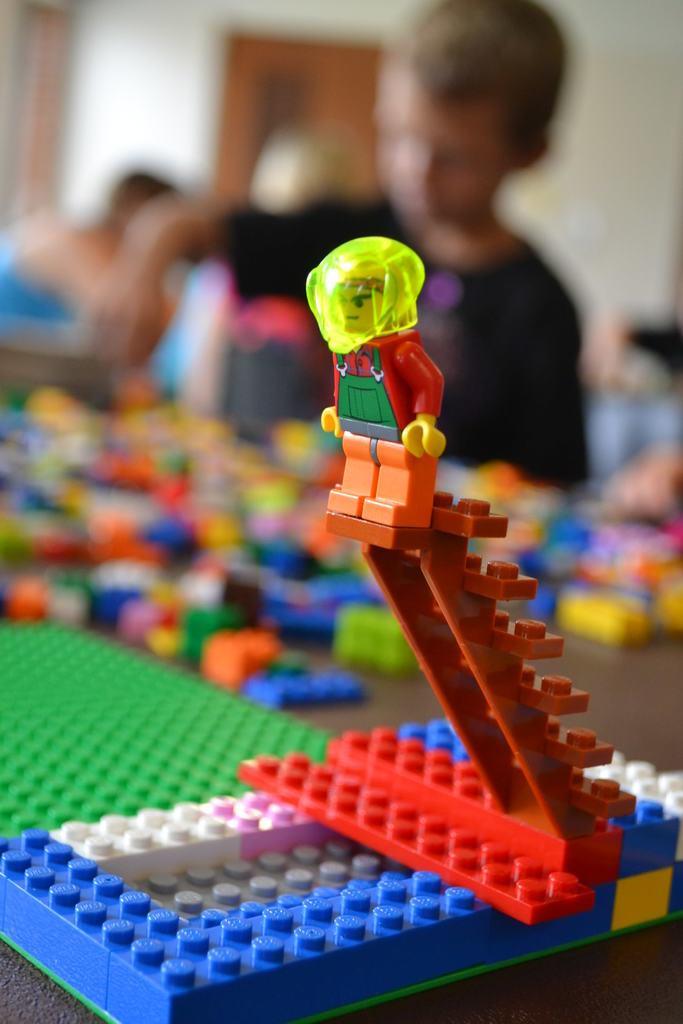Describe this image in one or two sentences. In the foreground, I can see building blocks and toys on a table. In the background, I can see a group of people, door and a wall. This image taken, maybe in a hall. 